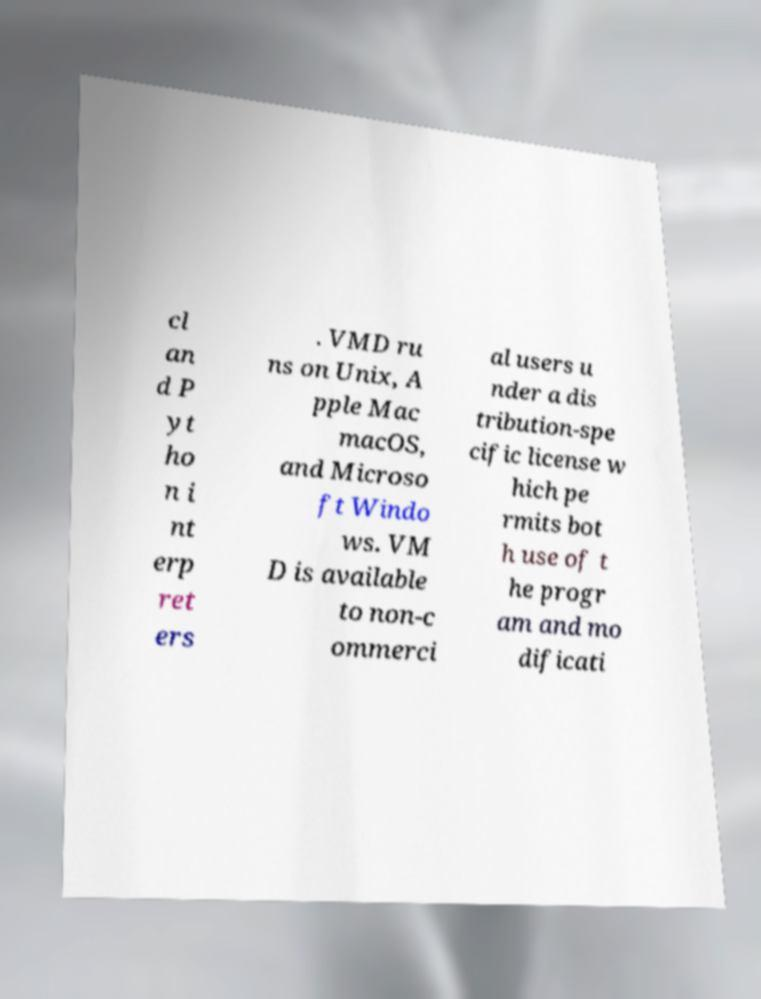Please identify and transcribe the text found in this image. cl an d P yt ho n i nt erp ret ers . VMD ru ns on Unix, A pple Mac macOS, and Microso ft Windo ws. VM D is available to non-c ommerci al users u nder a dis tribution-spe cific license w hich pe rmits bot h use of t he progr am and mo dificati 